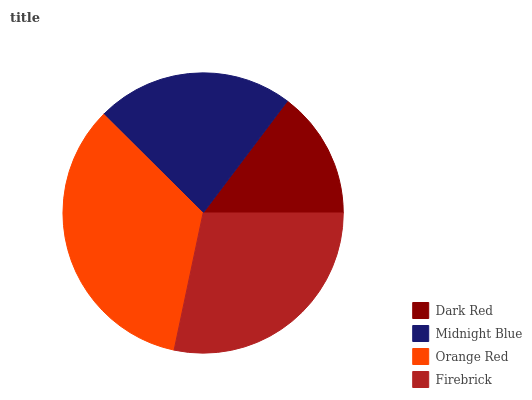Is Dark Red the minimum?
Answer yes or no. Yes. Is Orange Red the maximum?
Answer yes or no. Yes. Is Midnight Blue the minimum?
Answer yes or no. No. Is Midnight Blue the maximum?
Answer yes or no. No. Is Midnight Blue greater than Dark Red?
Answer yes or no. Yes. Is Dark Red less than Midnight Blue?
Answer yes or no. Yes. Is Dark Red greater than Midnight Blue?
Answer yes or no. No. Is Midnight Blue less than Dark Red?
Answer yes or no. No. Is Firebrick the high median?
Answer yes or no. Yes. Is Midnight Blue the low median?
Answer yes or no. Yes. Is Orange Red the high median?
Answer yes or no. No. Is Dark Red the low median?
Answer yes or no. No. 